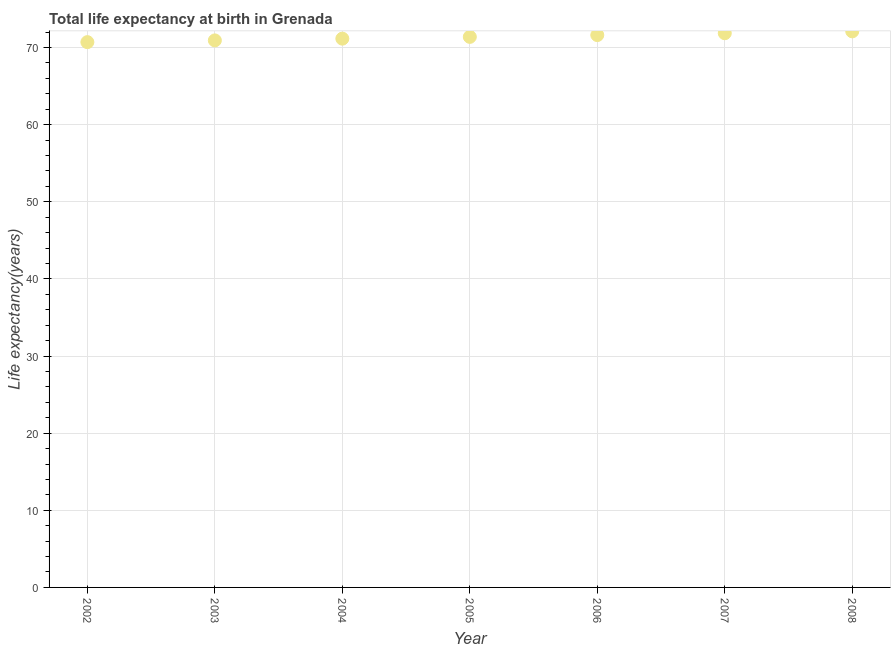What is the life expectancy at birth in 2008?
Make the answer very short. 72.09. Across all years, what is the maximum life expectancy at birth?
Ensure brevity in your answer.  72.09. Across all years, what is the minimum life expectancy at birth?
Your answer should be very brief. 70.69. In which year was the life expectancy at birth minimum?
Provide a succinct answer. 2002. What is the sum of the life expectancy at birth?
Your answer should be very brief. 499.66. What is the difference between the life expectancy at birth in 2002 and 2005?
Keep it short and to the point. -0.68. What is the average life expectancy at birth per year?
Your response must be concise. 71.38. What is the median life expectancy at birth?
Ensure brevity in your answer.  71.37. Do a majority of the years between 2004 and 2006 (inclusive) have life expectancy at birth greater than 64 years?
Your answer should be compact. Yes. What is the ratio of the life expectancy at birth in 2004 to that in 2006?
Your answer should be compact. 0.99. Is the difference between the life expectancy at birth in 2003 and 2007 greater than the difference between any two years?
Provide a short and direct response. No. What is the difference between the highest and the second highest life expectancy at birth?
Provide a succinct answer. 0.24. Is the sum of the life expectancy at birth in 2002 and 2008 greater than the maximum life expectancy at birth across all years?
Provide a succinct answer. Yes. What is the difference between the highest and the lowest life expectancy at birth?
Provide a short and direct response. 1.4. In how many years, is the life expectancy at birth greater than the average life expectancy at birth taken over all years?
Ensure brevity in your answer.  3. How many dotlines are there?
Offer a very short reply. 1. What is the difference between two consecutive major ticks on the Y-axis?
Offer a very short reply. 10. What is the title of the graph?
Your response must be concise. Total life expectancy at birth in Grenada. What is the label or title of the Y-axis?
Offer a terse response. Life expectancy(years). What is the Life expectancy(years) in 2002?
Offer a very short reply. 70.69. What is the Life expectancy(years) in 2003?
Provide a succinct answer. 70.92. What is the Life expectancy(years) in 2004?
Keep it short and to the point. 71.14. What is the Life expectancy(years) in 2005?
Keep it short and to the point. 71.37. What is the Life expectancy(years) in 2006?
Provide a succinct answer. 71.61. What is the Life expectancy(years) in 2007?
Make the answer very short. 71.84. What is the Life expectancy(years) in 2008?
Your response must be concise. 72.09. What is the difference between the Life expectancy(years) in 2002 and 2003?
Your answer should be compact. -0.23. What is the difference between the Life expectancy(years) in 2002 and 2004?
Provide a succinct answer. -0.45. What is the difference between the Life expectancy(years) in 2002 and 2005?
Keep it short and to the point. -0.68. What is the difference between the Life expectancy(years) in 2002 and 2006?
Your response must be concise. -0.92. What is the difference between the Life expectancy(years) in 2002 and 2007?
Ensure brevity in your answer.  -1.15. What is the difference between the Life expectancy(years) in 2002 and 2008?
Ensure brevity in your answer.  -1.4. What is the difference between the Life expectancy(years) in 2003 and 2004?
Offer a very short reply. -0.23. What is the difference between the Life expectancy(years) in 2003 and 2005?
Ensure brevity in your answer.  -0.46. What is the difference between the Life expectancy(years) in 2003 and 2006?
Your response must be concise. -0.69. What is the difference between the Life expectancy(years) in 2003 and 2007?
Give a very brief answer. -0.93. What is the difference between the Life expectancy(years) in 2003 and 2008?
Make the answer very short. -1.17. What is the difference between the Life expectancy(years) in 2004 and 2005?
Offer a very short reply. -0.23. What is the difference between the Life expectancy(years) in 2004 and 2006?
Offer a very short reply. -0.46. What is the difference between the Life expectancy(years) in 2004 and 2007?
Provide a short and direct response. -0.7. What is the difference between the Life expectancy(years) in 2004 and 2008?
Offer a terse response. -0.94. What is the difference between the Life expectancy(years) in 2005 and 2006?
Your response must be concise. -0.23. What is the difference between the Life expectancy(years) in 2005 and 2007?
Offer a very short reply. -0.47. What is the difference between the Life expectancy(years) in 2005 and 2008?
Provide a short and direct response. -0.72. What is the difference between the Life expectancy(years) in 2006 and 2007?
Your answer should be compact. -0.24. What is the difference between the Life expectancy(years) in 2006 and 2008?
Offer a very short reply. -0.48. What is the difference between the Life expectancy(years) in 2007 and 2008?
Offer a terse response. -0.24. What is the ratio of the Life expectancy(years) in 2002 to that in 2003?
Provide a succinct answer. 1. What is the ratio of the Life expectancy(years) in 2002 to that in 2005?
Offer a very short reply. 0.99. What is the ratio of the Life expectancy(years) in 2002 to that in 2006?
Provide a succinct answer. 0.99. What is the ratio of the Life expectancy(years) in 2002 to that in 2007?
Make the answer very short. 0.98. What is the ratio of the Life expectancy(years) in 2003 to that in 2004?
Your response must be concise. 1. What is the ratio of the Life expectancy(years) in 2003 to that in 2005?
Your answer should be very brief. 0.99. What is the ratio of the Life expectancy(years) in 2003 to that in 2006?
Provide a succinct answer. 0.99. What is the ratio of the Life expectancy(years) in 2003 to that in 2007?
Provide a short and direct response. 0.99. What is the ratio of the Life expectancy(years) in 2003 to that in 2008?
Offer a very short reply. 0.98. What is the ratio of the Life expectancy(years) in 2004 to that in 2005?
Give a very brief answer. 1. What is the ratio of the Life expectancy(years) in 2004 to that in 2006?
Make the answer very short. 0.99. What is the ratio of the Life expectancy(years) in 2004 to that in 2007?
Offer a very short reply. 0.99. What is the ratio of the Life expectancy(years) in 2004 to that in 2008?
Your response must be concise. 0.99. What is the ratio of the Life expectancy(years) in 2005 to that in 2006?
Your answer should be compact. 1. What is the ratio of the Life expectancy(years) in 2005 to that in 2007?
Provide a succinct answer. 0.99. What is the ratio of the Life expectancy(years) in 2006 to that in 2007?
Provide a short and direct response. 1. 